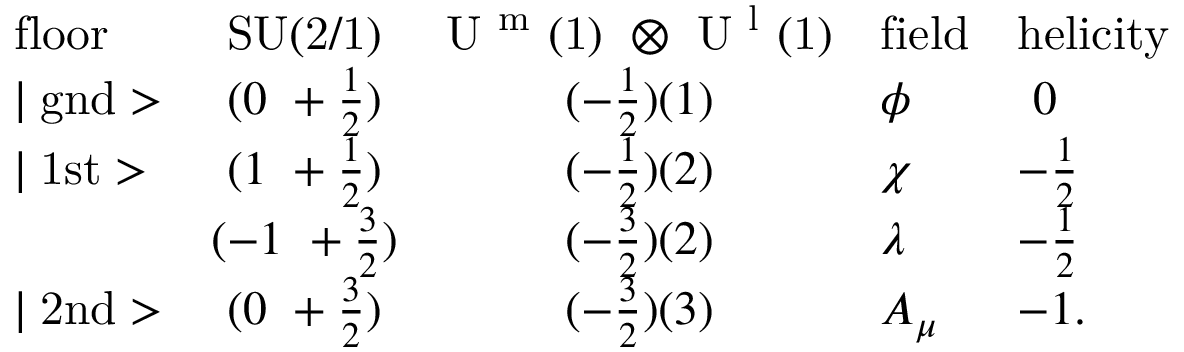Convert formula to latex. <formula><loc_0><loc_0><loc_500><loc_500>\begin{array} { l c c l l } { f l o o r } & { S U ( 2 / 1 ) } & { { U ^ { m } ( 1 ) \otimes U ^ { l } ( 1 ) } } & { f i e l d } & { h e l i c i t y } \\ { | g n d > } & { { ( 0 + \frac { 1 } { 2 } ) } } & { { ( - \frac { 1 } { 2 } ) ( 1 ) } } & { \phi } & { 0 } \\ { | 1 s t > } & { { ( 1 + \frac { 1 } { 2 } ) } } & { { ( - \frac { 1 } { 2 } ) ( 2 ) } } & { \chi } & { { - \frac { 1 } { 2 } } } & { { ( - 1 + \frac { 3 } { 2 } ) } } & { { ( - \frac { 3 } { 2 } ) ( 2 ) } } & { \lambda } & { { - \frac { 1 } { 2 } } } \\ { | 2 n d > } & { { ( 0 + \frac { 3 } { 2 } ) } } & { { ( - \frac { 3 } { 2 } ) ( 3 ) } } & { { A _ { \mu } } } & { - 1 . } \end{array}</formula> 